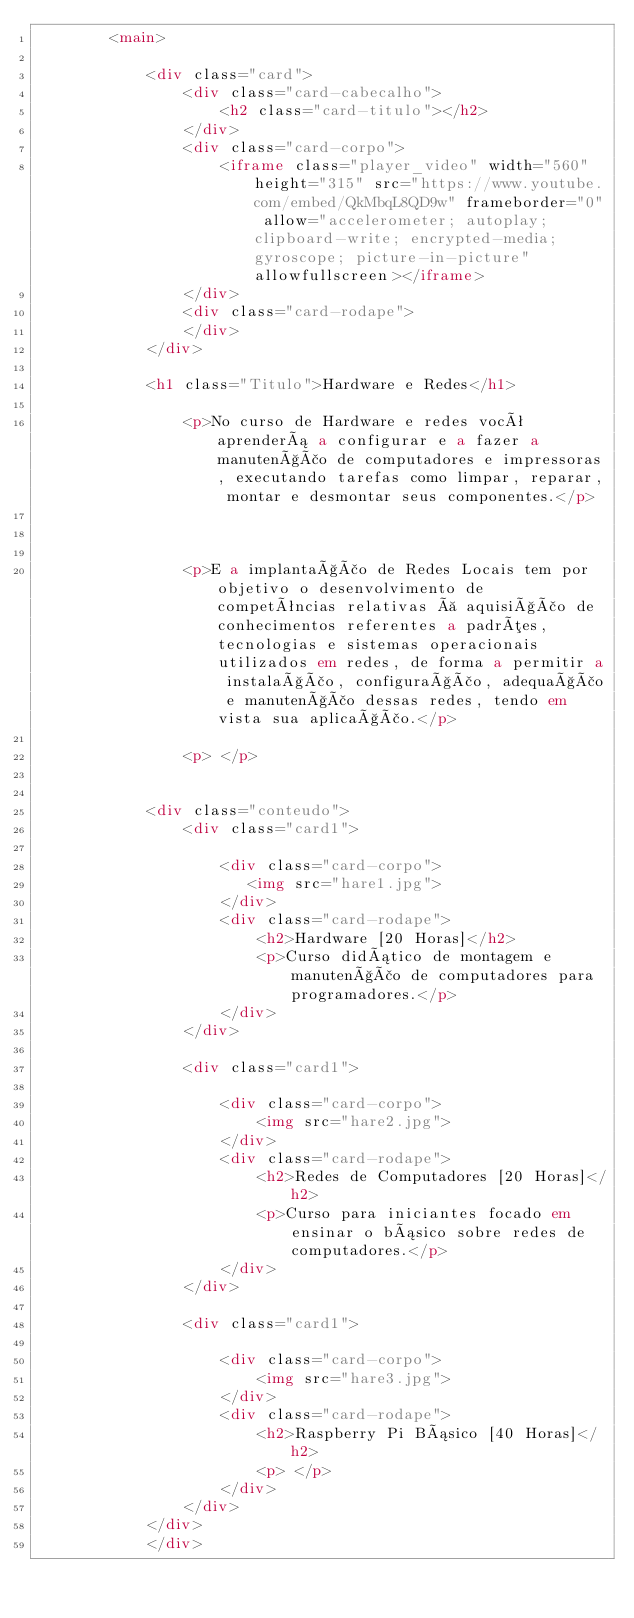Convert code to text. <code><loc_0><loc_0><loc_500><loc_500><_HTML_>        <main>

            <div class="card">
                <div class="card-cabecalho">
                    <h2 class="card-titulo"></h2>
                </div>
                <div class="card-corpo">
                    <iframe class="player_video" width="560" height="315" src="https://www.youtube.com/embed/QkMbqL8QD9w" frameborder="0" allow="accelerometer; autoplay; clipboard-write; encrypted-media; gyroscope; picture-in-picture" allowfullscreen></iframe>
                </div>
                <div class="card-rodape">
                </div>
            </div>

            <h1 class="Titulo">Hardware e Redes</h1>

                <p>No curso de Hardware e redes você aprenderá a configurar e a fazer a manutenção de computadores e impressoras, executando tarefas como limpar, reparar, montar e desmontar seus componentes.</p>

            

                <p>E a implantação de Redes Locais tem por objetivo o desenvolvimento de competências relativas à aquisição de conhecimentos referentes a padrões, tecnologias e sistemas operacionais utilizados em redes, de forma a permitir a instalação, configuração, adequação e manutenção dessas redes, tendo em vista sua aplicação.</p>
               
                <p> </p>
        
        
            <div class="conteudo">
                <div class="card1">
                    
                    <div class="card-corpo">
                       <img src="hare1.jpg">
                    </div>
                    <div class="card-rodape">
                        <h2>Hardware [20 Horas]</h2>
                        <p>Curso didático de montagem e manutenção de computadores para programadores.</p>
                    </div>
                </div>

                <div class="card1">
                    
                    <div class="card-corpo">
                        <img src="hare2.jpg">
                    </div>
                    <div class="card-rodape">
                        <h2>Redes de Computadores [20 Horas]</h2>
                        <p>Curso para iniciantes focado em ensinar o básico sobre redes de computadores.</p>
                    </div>
                </div>

                <div class="card1">
                    
                    <div class="card-corpo">
                        <img src="hare3.jpg">
                    </div>
                    <div class="card-rodape">
                        <h2>Raspberry Pi Básico [40 Horas]</h2>
                        <p> </p>
                    </div>
                </div>
            </div>
            </div>
            </code> 